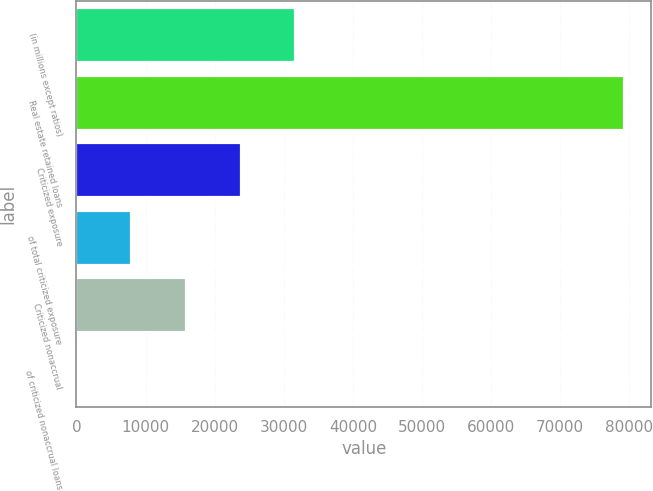Convert chart to OTSL. <chart><loc_0><loc_0><loc_500><loc_500><bar_chart><fcel>(in millions except ratios)<fcel>Real estate retained loans<fcel>Criticized exposure<fcel>of total criticized exposure<fcel>Criticized nonaccrual<fcel>of criticized nonaccrual loans<nl><fcel>31673.6<fcel>79184<fcel>23755.2<fcel>7918.46<fcel>15836.9<fcel>0.07<nl></chart> 